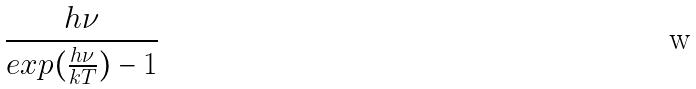<formula> <loc_0><loc_0><loc_500><loc_500>\frac { h \nu } { e x p ( \frac { h \nu } { k T } ) - 1 }</formula> 